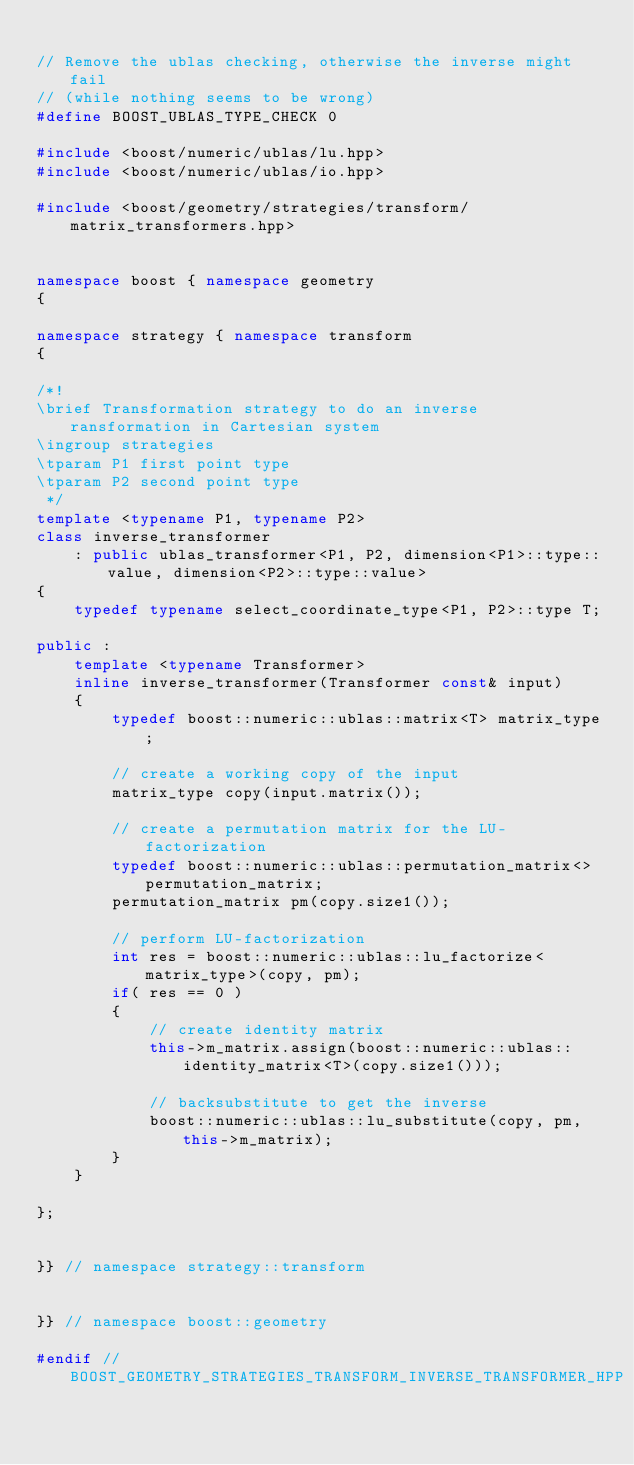Convert code to text. <code><loc_0><loc_0><loc_500><loc_500><_C++_>
// Remove the ublas checking, otherwise the inverse might fail
// (while nothing seems to be wrong)
#define BOOST_UBLAS_TYPE_CHECK 0

#include <boost/numeric/ublas/lu.hpp>
#include <boost/numeric/ublas/io.hpp>

#include <boost/geometry/strategies/transform/matrix_transformers.hpp>


namespace boost { namespace geometry
{

namespace strategy { namespace transform
{

/*!
\brief Transformation strategy to do an inverse ransformation in Cartesian system
\ingroup strategies
\tparam P1 first point type
\tparam P2 second point type
 */
template <typename P1, typename P2>
class inverse_transformer
    : public ublas_transformer<P1, P2, dimension<P1>::type::value, dimension<P2>::type::value>
{
    typedef typename select_coordinate_type<P1, P2>::type T;

public :
    template <typename Transformer>
    inline inverse_transformer(Transformer const& input)
    {
        typedef boost::numeric::ublas::matrix<T> matrix_type;

        // create a working copy of the input
        matrix_type copy(input.matrix());

        // create a permutation matrix for the LU-factorization
        typedef boost::numeric::ublas::permutation_matrix<> permutation_matrix;
        permutation_matrix pm(copy.size1());

        // perform LU-factorization
        int res = boost::numeric::ublas::lu_factorize<matrix_type>(copy, pm);
        if( res == 0 )
        {
            // create identity matrix
            this->m_matrix.assign(boost::numeric::ublas::identity_matrix<T>(copy.size1()));

            // backsubstitute to get the inverse
            boost::numeric::ublas::lu_substitute(copy, pm, this->m_matrix);
        }
    }

};


}} // namespace strategy::transform


}} // namespace boost::geometry

#endif // BOOST_GEOMETRY_STRATEGIES_TRANSFORM_INVERSE_TRANSFORMER_HPP
</code> 